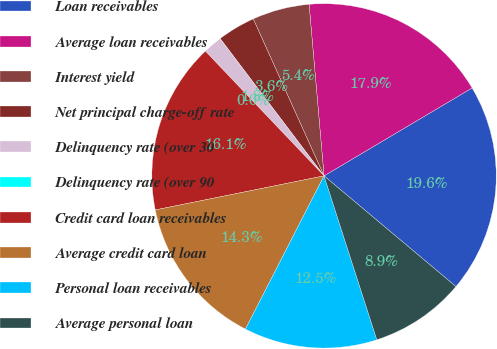Convert chart to OTSL. <chart><loc_0><loc_0><loc_500><loc_500><pie_chart><fcel>Loan receivables<fcel>Average loan receivables<fcel>Interest yield<fcel>Net principal charge-off rate<fcel>Delinquency rate (over 30<fcel>Delinquency rate (over 90<fcel>Credit card loan receivables<fcel>Average credit card loan<fcel>Personal loan receivables<fcel>Average personal loan<nl><fcel>19.64%<fcel>17.86%<fcel>5.36%<fcel>3.57%<fcel>1.79%<fcel>0.0%<fcel>16.07%<fcel>14.29%<fcel>12.5%<fcel>8.93%<nl></chart> 